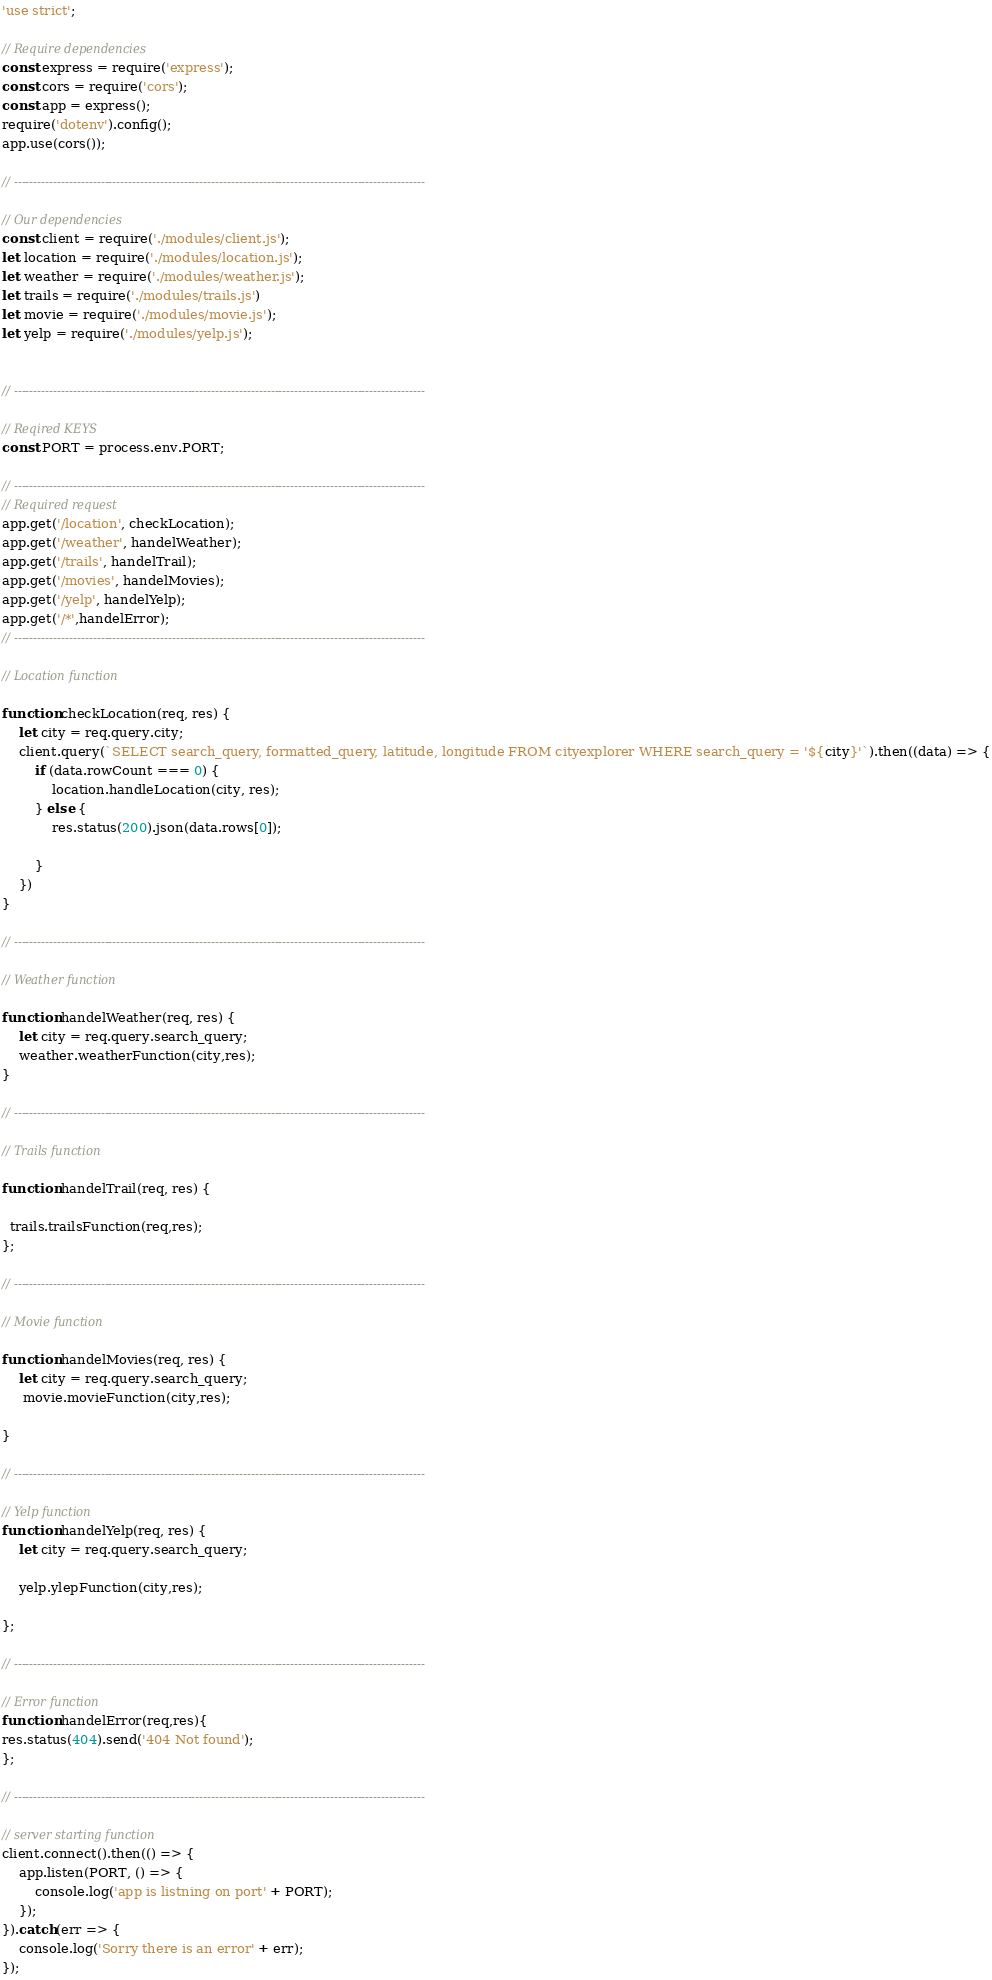<code> <loc_0><loc_0><loc_500><loc_500><_JavaScript_>
'use strict';

// Require dependencies
const express = require('express');
const cors = require('cors');
const app = express();
require('dotenv').config();
app.use(cors());

// --------------------------------------------------------------------------------------------------------

// Our dependencies
const client = require('./modules/client.js');
let location = require('./modules/location.js');
let weather = require('./modules/weather.js');
let trails = require('./modules/trails.js')
let movie = require('./modules/movie.js');
let yelp = require('./modules/yelp.js');


// --------------------------------------------------------------------------------------------------------

// Reqired KEYS
const PORT = process.env.PORT;

// --------------------------------------------------------------------------------------------------------
// Required request
app.get('/location', checkLocation);
app.get('/weather', handelWeather);
app.get('/trails', handelTrail);
app.get('/movies', handelMovies);
app.get('/yelp', handelYelp);
app.get('/*',handelError);
// --------------------------------------------------------------------------------------------------------

// Location function

function checkLocation(req, res) {
    let city = req.query.city;
    client.query(`SELECT search_query, formatted_query, latitude, longitude FROM cityexplorer WHERE search_query = '${city}'`).then((data) => {
        if (data.rowCount === 0) {
            location.handleLocation(city, res);
        } else {
            res.status(200).json(data.rows[0]);
            
        }
    })
}

// --------------------------------------------------------------------------------------------------------

// Weather function

function handelWeather(req, res) {
    let city = req.query.search_query;
    weather.weatherFunction(city,res);
}

// --------------------------------------------------------------------------------------------------------

// Trails function

function handelTrail(req, res) {

  trails.trailsFunction(req,res);
};

// --------------------------------------------------------------------------------------------------------

// Movie function

function handelMovies(req, res) {
    let city = req.query.search_query;
     movie.movieFunction(city,res);
   
}

// --------------------------------------------------------------------------------------------------------

// Yelp function
function handelYelp(req, res) {
    let city = req.query.search_query;

    yelp.ylepFunction(city,res);

};

// --------------------------------------------------------------------------------------------------------

// Error function
function handelError(req,res){
res.status(404).send('404 Not found');
};

// --------------------------------------------------------------------------------------------------------

// server starting function
client.connect().then(() => {
    app.listen(PORT, () => {
        console.log('app is listning on port' + PORT);
    });
}).catch(err => {
    console.log('Sorry there is an error' + err);
});</code> 